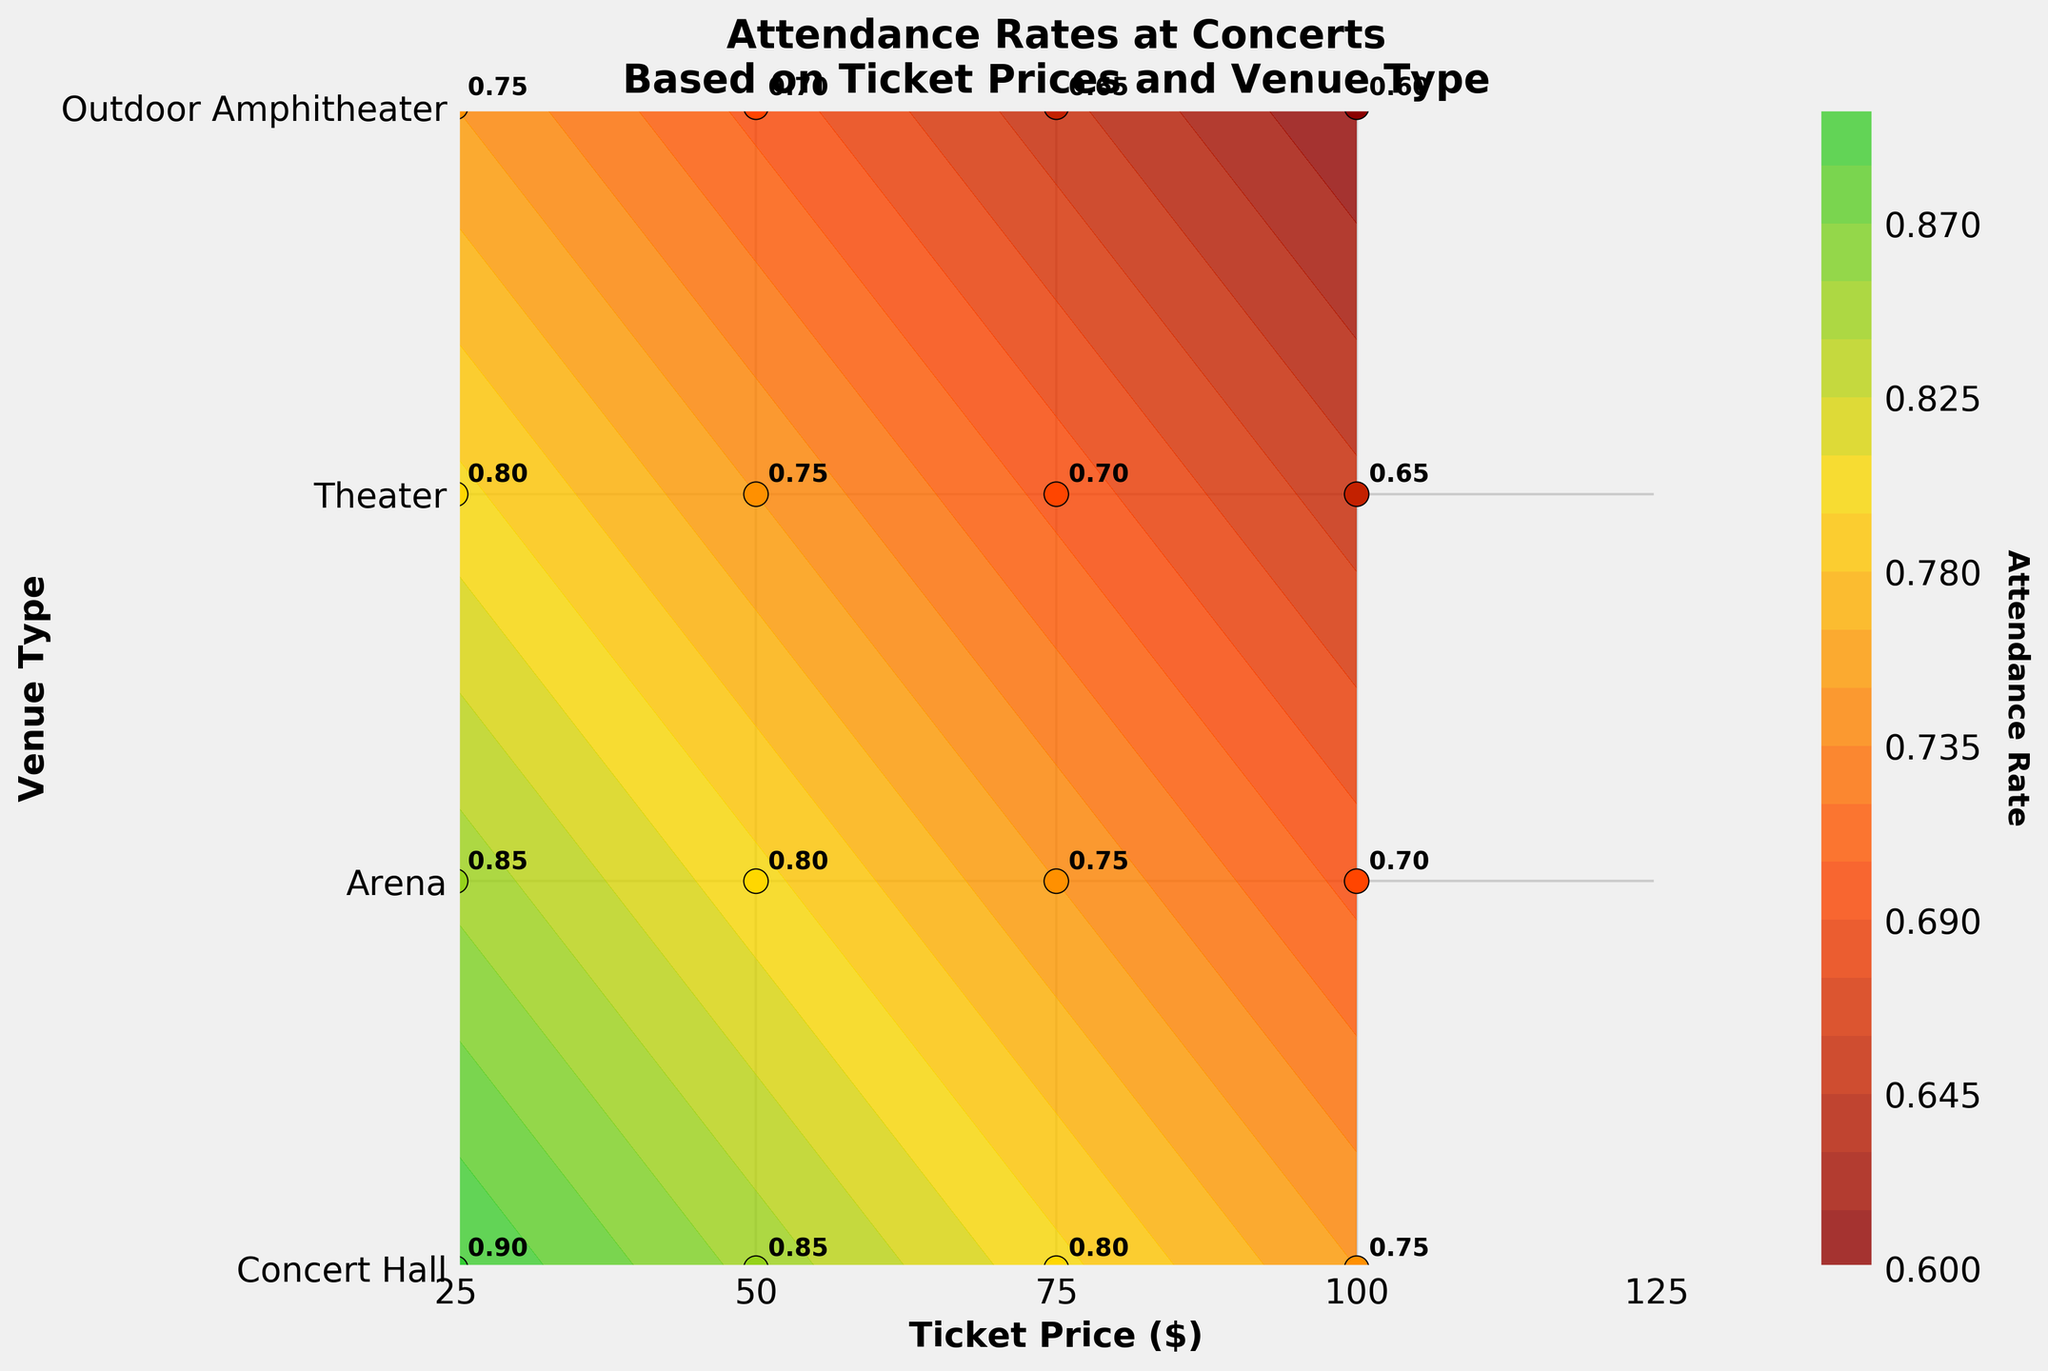What is the attendance rate at a Concert Hall when the ticket price is $100? The attendance rate values are labeled directly on the plot. Locate the point corresponding to a Concert Hall (y = 0) and a ticket price of $100 (x = 100).
Answer: 0.75 What is the title of the figure? The title is found at the top of the figure above the plot area.
Answer: Attendance Rates at Concerts Based on Ticket Prices and Venue Type Between an Arena and a Theater, which has a higher attendance rate at a ticket price of $50? Check the labeled values for both Arena (y = 1) and Theater (y = 2) at the ticket price of $50 (x = 50). The attendance rate is 0.80 for Arena and 0.75 for Theater, so Arena has the higher rate.
Answer: Arena What are the y-axis tick labels? The y-axis tick labels represent the types of venues and are found along the vertical axis.
Answer: Concert Hall, Arena, Theater, Outdoor Amphitheater What is the average attendance rate at an Outdoor Amphitheater for ticket prices between $25 and $100? Identify the attendance rates at Outdoor Amphitheater (y = 3) for ticket prices of $25, $50, $75, and $100 from the plot, which are 0.75, 0.70, 0.65, and 0.60 respectively. Calculate the average: (0.75 + 0.70 + 0.65 + 0.60) / 4 = 0.675.
Answer: 0.675 Which ticket price corresponds to the highest attendance rate for all venues? Find the highest labeled attendance rate on the plot, which is 0.90 at a Concert Hall (y=0) at a ticket price of $25 (x=25).
Answer: 25 What is the general trend of attendance rates as ticket prices increase? Observe the overall contour and labeled values. Attendance rates generally decrease as ticket prices increase across all venue types.
Answer: Decrease Among all venue types, which has the lowest attendance rate at a ticket price of $75? Check the labeled values for all venues at a ticket price of $75 (x = 75). The values are Concert Hall (0.80), Arena (0.75), Outdoor Amphitheater (0.65), and Theater (0.70). The lowest rate is 0.65 at the Outdoor Amphitheater.
Answer: Outdoor Amphitheater 